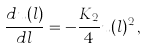Convert formula to latex. <formula><loc_0><loc_0><loc_500><loc_500>\frac { d u ( l ) } { d l } = - \frac { K _ { 2 } } { 4 } u ( l ) ^ { 2 } \, ,</formula> 